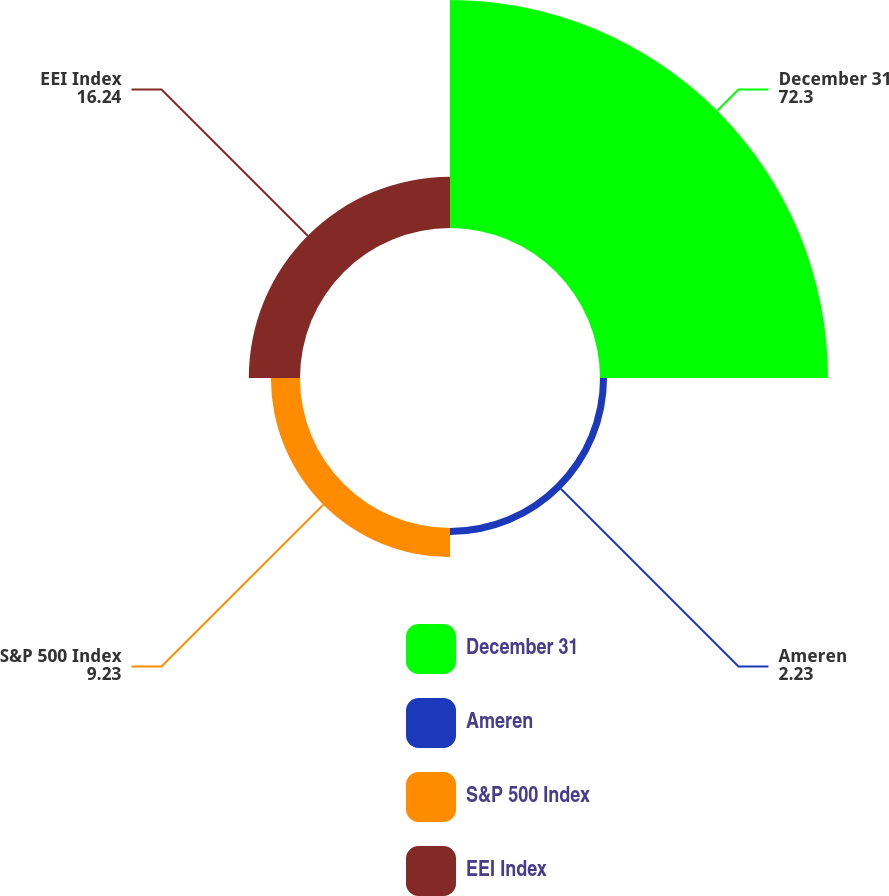Convert chart to OTSL. <chart><loc_0><loc_0><loc_500><loc_500><pie_chart><fcel>December 31<fcel>Ameren<fcel>S&P 500 Index<fcel>EEI Index<nl><fcel>72.3%<fcel>2.23%<fcel>9.23%<fcel>16.24%<nl></chart> 